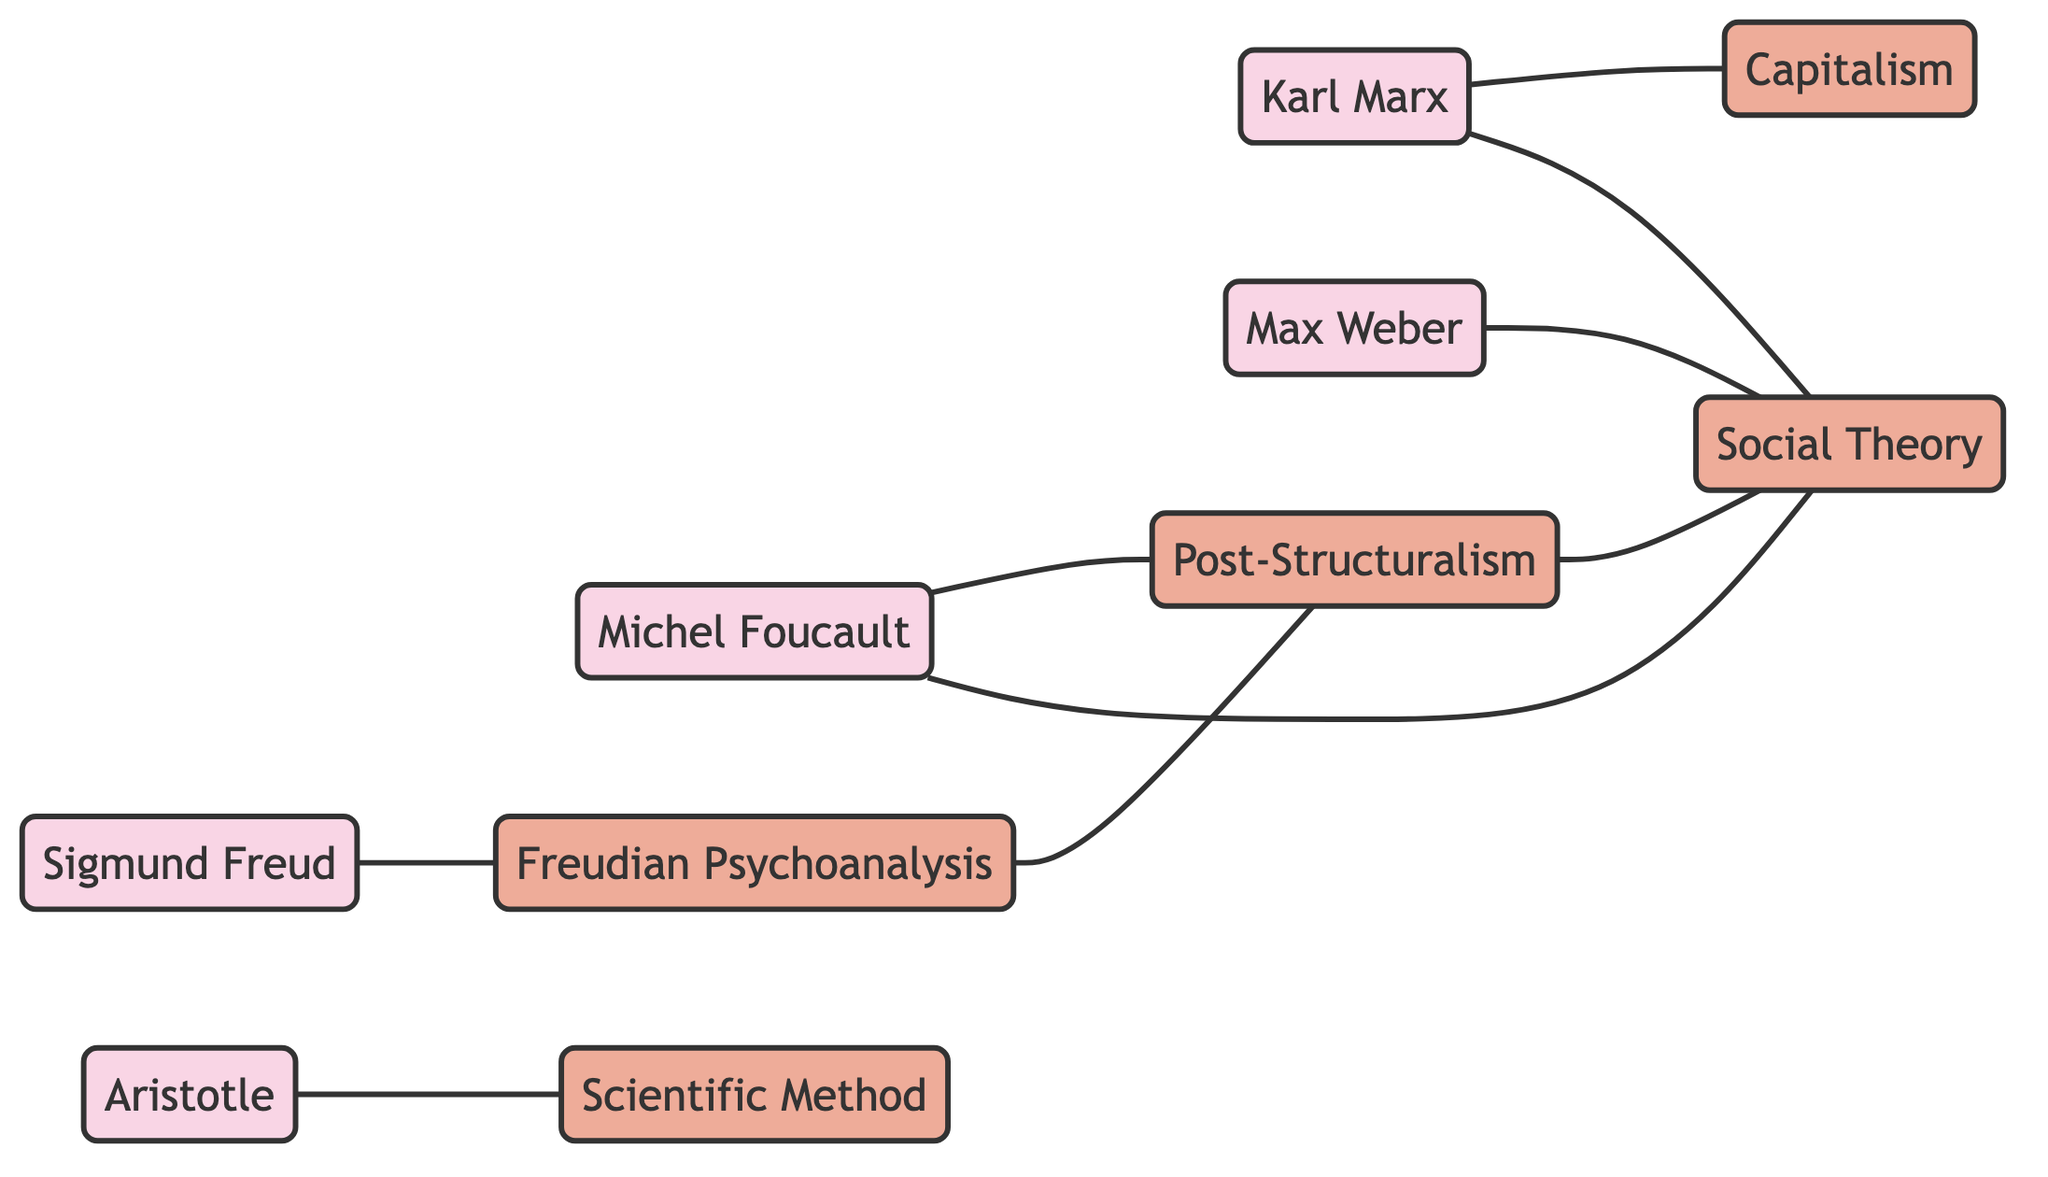What is the total number of theorists represented in the diagram? The diagram includes five theorists: Aristotle, Karl Marx, Max Weber, Sigmund Freud, and Michel Foucault. Counting these distinct nodes gives a total of five.
Answer: 5 Which theory is directly connected to Aristotle? The connection indicated in the diagram shows that Aristotle is directly linked to the Scientific Method. By observing the edge connecting these two nodes, we can determine the relationship.
Answer: Scientific Method How many theories are linked to Karl Marx? Upon examining Karl Marx's connections in the diagram, he has edges linking to two theories: Capitalism and Social Theory. Therefore, we count these connections to find the answer.
Answer: 2 Which theorist is the source for Freudian Psychoanalysis? The diagram indicates that Sigmund Freud is the sole theorist connected to Freudian Psychoanalysis, as there is a direct edge from Sigmund Freud to this theory.
Answer: Sigmund Freud What is the relationship between Post-Structuralism and Social Theory? The diagram reveals an edge that connects Post-Structuralism to Social Theory, indicating that there is a direct relationship between these two concepts.
Answer: Connected How many edges are in the diagram? To find the total number of edges, we can count each unique connection between nodes. The diagram shows a total of eight edges linking the theorists and their theories.
Answer: 8 Which theorist influences both Post-Structuralism and Social Theory? By inspecting the diagram, Michel Foucault is shown to have edges leading to both Post-Structuralism and Social Theory, indicating his influence on both.
Answer: Michel Foucault Is Freudian Psychoanalysis connected to Capitalism? Looking at the diagram, there is no direct edge linking Freudian Psychoanalysis to Capitalism. Thus, they are separate in the context of this diagram.
Answer: No What type of theories does Max Weber connect to in this graph? Max Weber is connected to Social Theory in the graph, as indicated by the edge that establishes this relationship.
Answer: Social Theory 